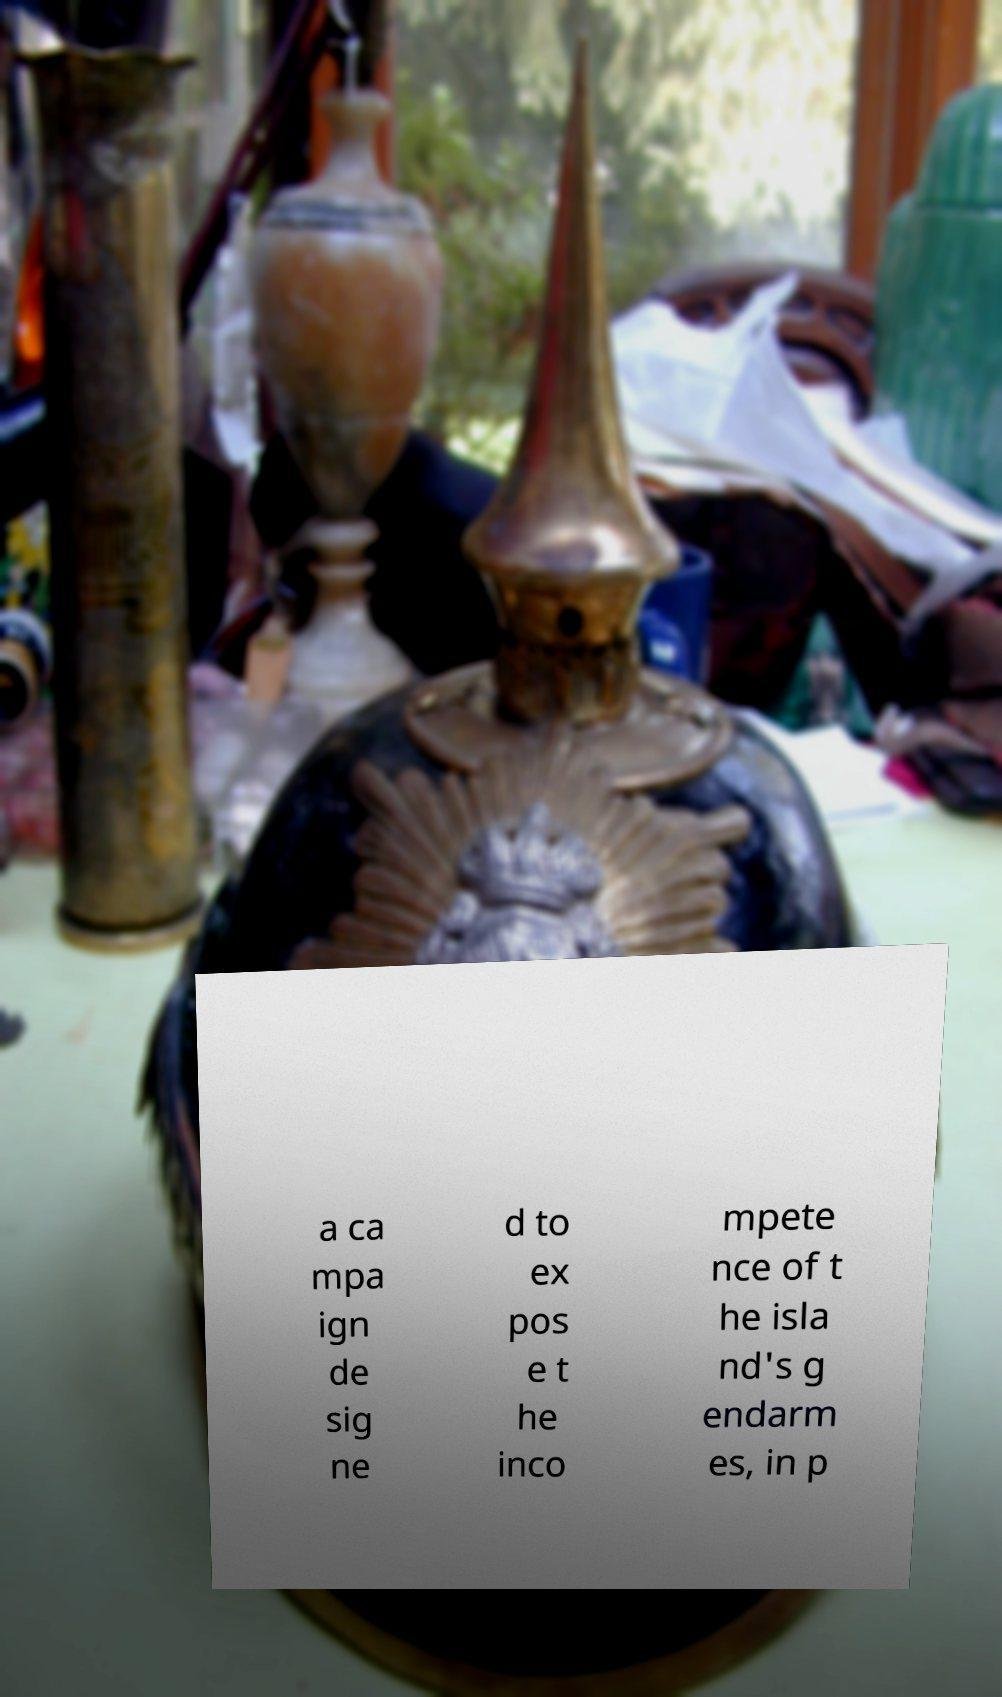I need the written content from this picture converted into text. Can you do that? a ca mpa ign de sig ne d to ex pos e t he inco mpete nce of t he isla nd's g endarm es, in p 